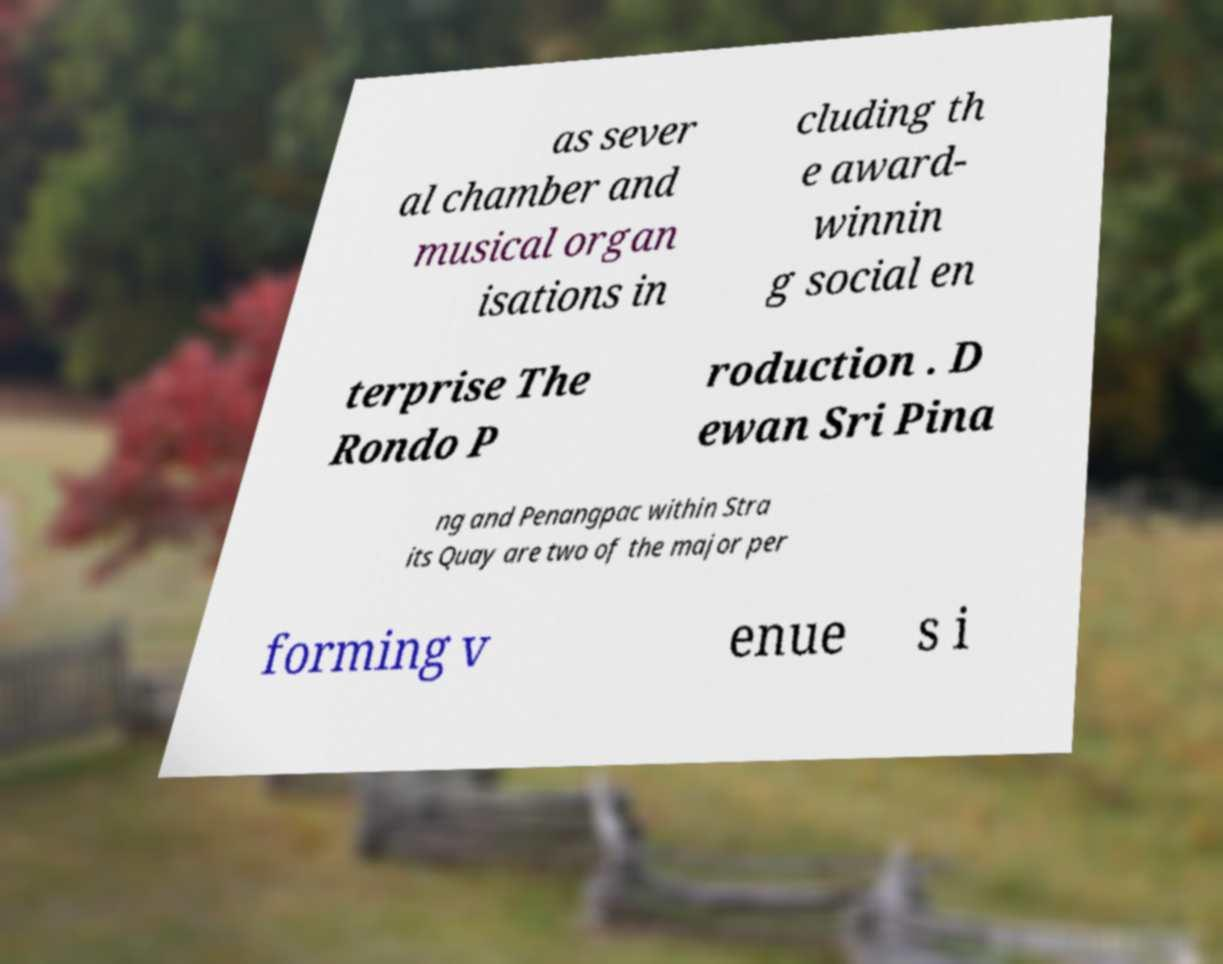There's text embedded in this image that I need extracted. Can you transcribe it verbatim? as sever al chamber and musical organ isations in cluding th e award- winnin g social en terprise The Rondo P roduction . D ewan Sri Pina ng and Penangpac within Stra its Quay are two of the major per forming v enue s i 